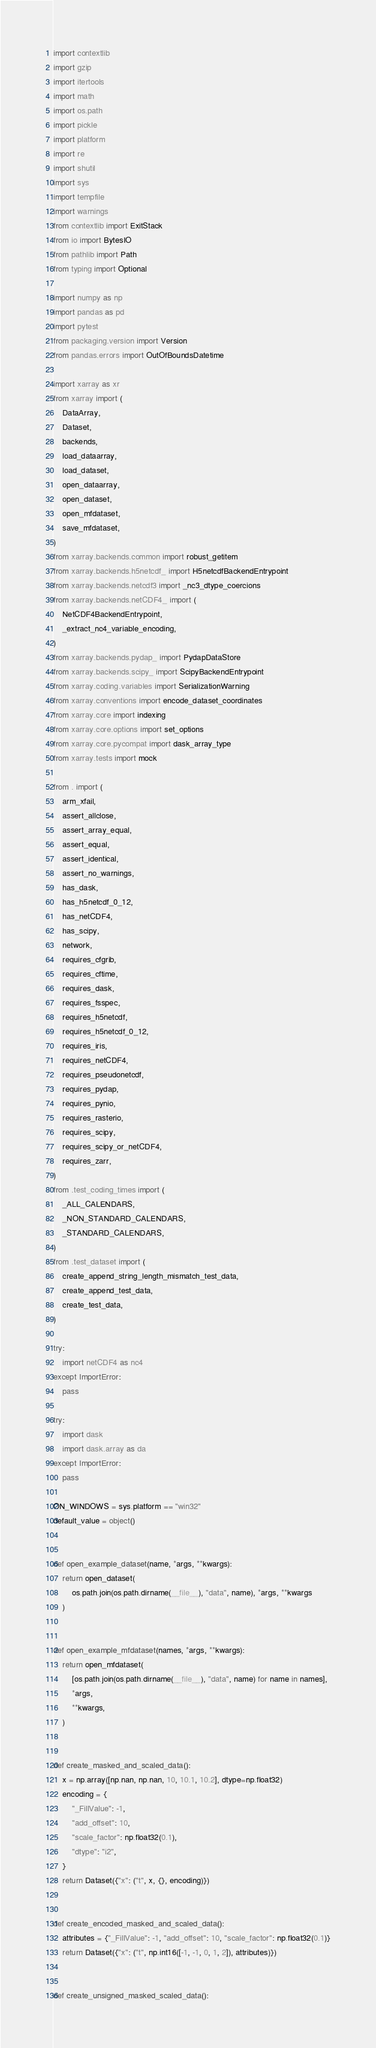<code> <loc_0><loc_0><loc_500><loc_500><_Python_>import contextlib
import gzip
import itertools
import math
import os.path
import pickle
import platform
import re
import shutil
import sys
import tempfile
import warnings
from contextlib import ExitStack
from io import BytesIO
from pathlib import Path
from typing import Optional

import numpy as np
import pandas as pd
import pytest
from packaging.version import Version
from pandas.errors import OutOfBoundsDatetime

import xarray as xr
from xarray import (
    DataArray,
    Dataset,
    backends,
    load_dataarray,
    load_dataset,
    open_dataarray,
    open_dataset,
    open_mfdataset,
    save_mfdataset,
)
from xarray.backends.common import robust_getitem
from xarray.backends.h5netcdf_ import H5netcdfBackendEntrypoint
from xarray.backends.netcdf3 import _nc3_dtype_coercions
from xarray.backends.netCDF4_ import (
    NetCDF4BackendEntrypoint,
    _extract_nc4_variable_encoding,
)
from xarray.backends.pydap_ import PydapDataStore
from xarray.backends.scipy_ import ScipyBackendEntrypoint
from xarray.coding.variables import SerializationWarning
from xarray.conventions import encode_dataset_coordinates
from xarray.core import indexing
from xarray.core.options import set_options
from xarray.core.pycompat import dask_array_type
from xarray.tests import mock

from . import (
    arm_xfail,
    assert_allclose,
    assert_array_equal,
    assert_equal,
    assert_identical,
    assert_no_warnings,
    has_dask,
    has_h5netcdf_0_12,
    has_netCDF4,
    has_scipy,
    network,
    requires_cfgrib,
    requires_cftime,
    requires_dask,
    requires_fsspec,
    requires_h5netcdf,
    requires_h5netcdf_0_12,
    requires_iris,
    requires_netCDF4,
    requires_pseudonetcdf,
    requires_pydap,
    requires_pynio,
    requires_rasterio,
    requires_scipy,
    requires_scipy_or_netCDF4,
    requires_zarr,
)
from .test_coding_times import (
    _ALL_CALENDARS,
    _NON_STANDARD_CALENDARS,
    _STANDARD_CALENDARS,
)
from .test_dataset import (
    create_append_string_length_mismatch_test_data,
    create_append_test_data,
    create_test_data,
)

try:
    import netCDF4 as nc4
except ImportError:
    pass

try:
    import dask
    import dask.array as da
except ImportError:
    pass

ON_WINDOWS = sys.platform == "win32"
default_value = object()


def open_example_dataset(name, *args, **kwargs):
    return open_dataset(
        os.path.join(os.path.dirname(__file__), "data", name), *args, **kwargs
    )


def open_example_mfdataset(names, *args, **kwargs):
    return open_mfdataset(
        [os.path.join(os.path.dirname(__file__), "data", name) for name in names],
        *args,
        **kwargs,
    )


def create_masked_and_scaled_data():
    x = np.array([np.nan, np.nan, 10, 10.1, 10.2], dtype=np.float32)
    encoding = {
        "_FillValue": -1,
        "add_offset": 10,
        "scale_factor": np.float32(0.1),
        "dtype": "i2",
    }
    return Dataset({"x": ("t", x, {}, encoding)})


def create_encoded_masked_and_scaled_data():
    attributes = {"_FillValue": -1, "add_offset": 10, "scale_factor": np.float32(0.1)}
    return Dataset({"x": ("t", np.int16([-1, -1, 0, 1, 2]), attributes)})


def create_unsigned_masked_scaled_data():</code> 